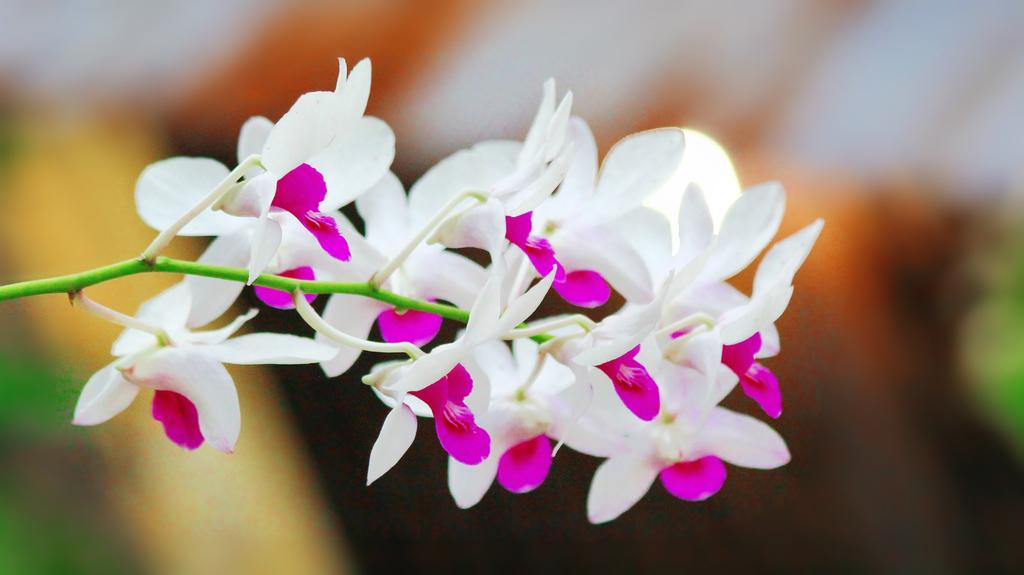What is the main subject in the center of the image? There are flowers in the center of the image. Can you describe the background of the image? There are objects in the background of the image. What type of oil can be seen dripping from the flowers in the image? There is no oil present in the image, and the flowers are not depicted as dripping any substance. 